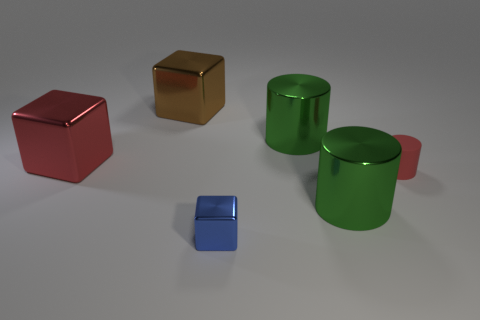Subtract 1 blocks. How many blocks are left? 2 Add 1 large brown objects. How many objects exist? 7 Subtract all brown metallic blocks. How many blocks are left? 2 Subtract all red cylinders. How many cylinders are left? 2 Subtract all purple spheres. How many yellow cylinders are left? 0 Subtract all small red rubber cylinders. Subtract all big red metallic things. How many objects are left? 4 Add 4 tiny blue shiny objects. How many tiny blue shiny objects are left? 5 Add 4 big red metal blocks. How many big red metal blocks exist? 5 Subtract 0 cyan balls. How many objects are left? 6 Subtract all purple cubes. Subtract all blue cylinders. How many cubes are left? 3 